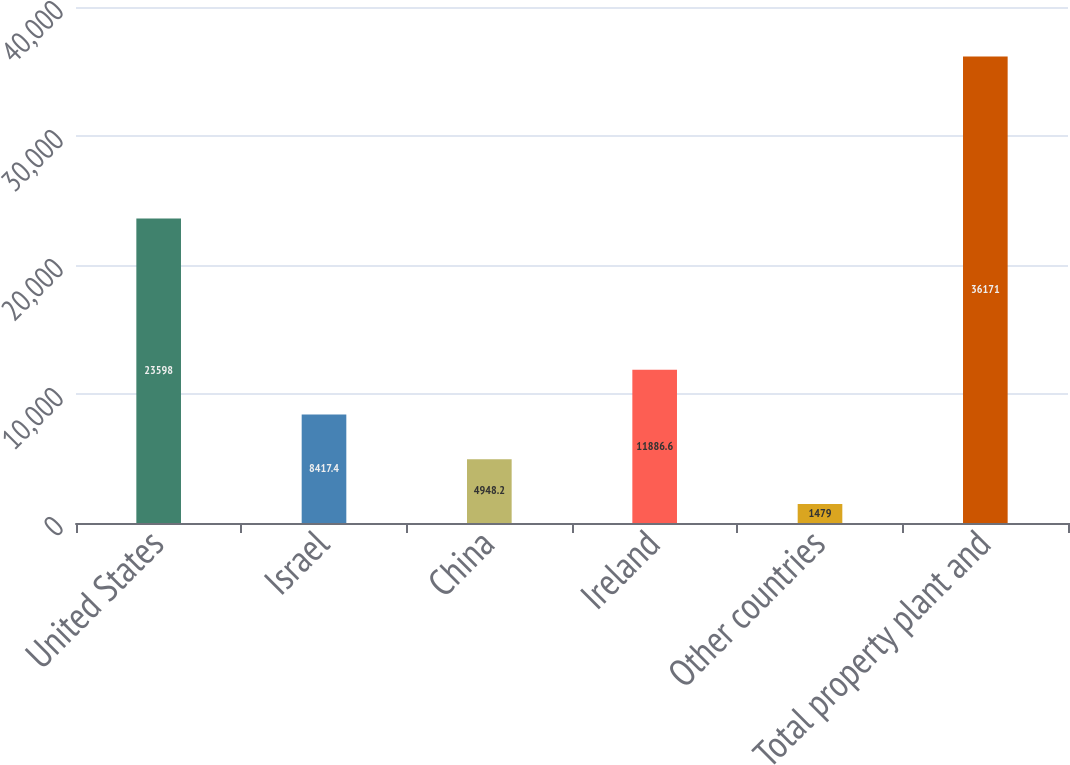Convert chart to OTSL. <chart><loc_0><loc_0><loc_500><loc_500><bar_chart><fcel>United States<fcel>Israel<fcel>China<fcel>Ireland<fcel>Other countries<fcel>Total property plant and<nl><fcel>23598<fcel>8417.4<fcel>4948.2<fcel>11886.6<fcel>1479<fcel>36171<nl></chart> 